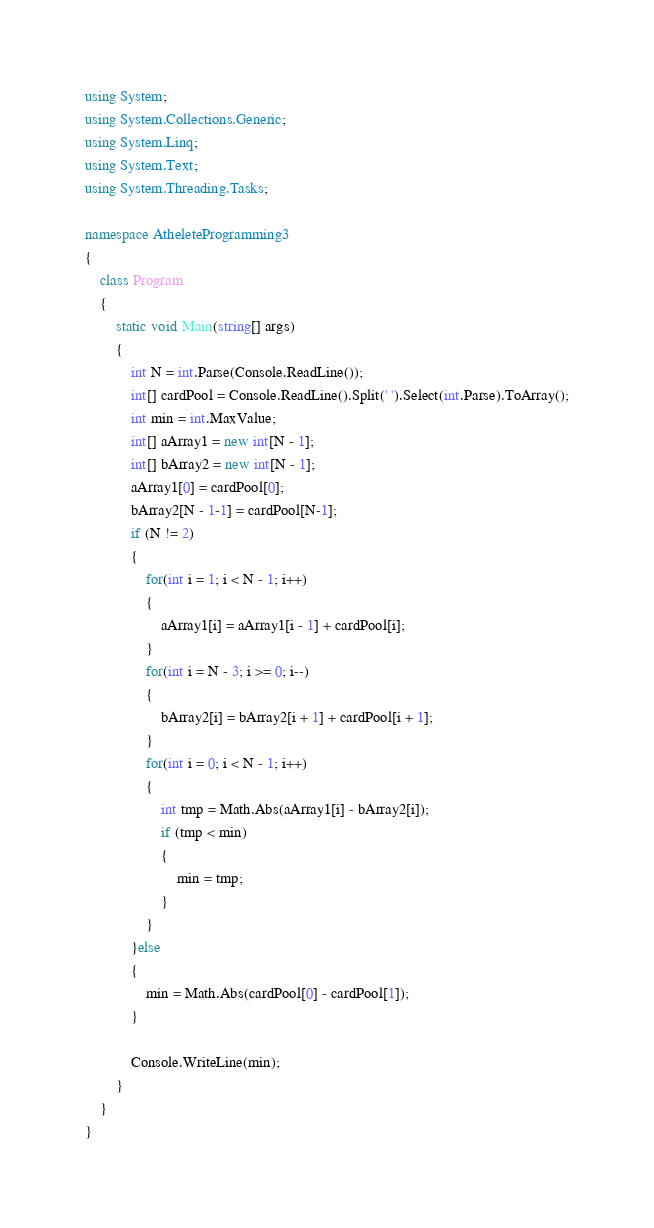<code> <loc_0><loc_0><loc_500><loc_500><_C#_>using System;
using System.Collections.Generic;
using System.Linq;
using System.Text;
using System.Threading.Tasks;

namespace AtheleteProgramming3
{
    class Program
    {
        static void Main(string[] args)
        {
            int N = int.Parse(Console.ReadLine());
            int[] cardPool = Console.ReadLine().Split(' ').Select(int.Parse).ToArray();
            int min = int.MaxValue;
            int[] aArray1 = new int[N - 1];
            int[] bArray2 = new int[N - 1];
            aArray1[0] = cardPool[0];
            bArray2[N - 1-1] = cardPool[N-1];
            if (N != 2)
            {
                for(int i = 1; i < N - 1; i++)
                {
                    aArray1[i] = aArray1[i - 1] + cardPool[i];
                }
                for(int i = N - 3; i >= 0; i--)
                {
                    bArray2[i] = bArray2[i + 1] + cardPool[i + 1];
                }
                for(int i = 0; i < N - 1; i++)
                {
                    int tmp = Math.Abs(aArray1[i] - bArray2[i]);
                    if (tmp < min)
                    {
                        min = tmp;
                    }
                }
            }else
            {
                min = Math.Abs(cardPool[0] - cardPool[1]);
            }

            Console.WriteLine(min);
        }
    }
}
</code> 